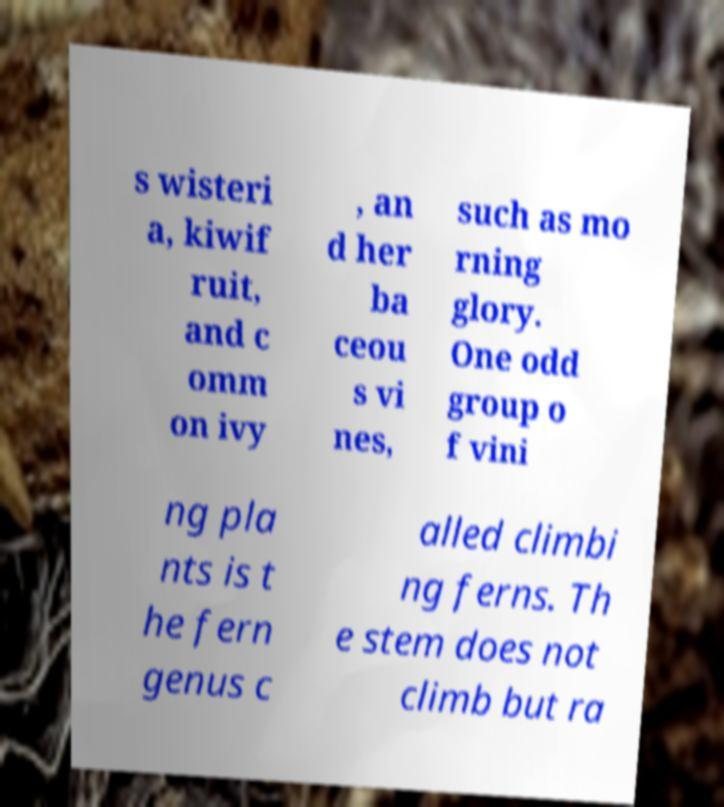Can you accurately transcribe the text from the provided image for me? s wisteri a, kiwif ruit, and c omm on ivy , an d her ba ceou s vi nes, such as mo rning glory. One odd group o f vini ng pla nts is t he fern genus c alled climbi ng ferns. Th e stem does not climb but ra 